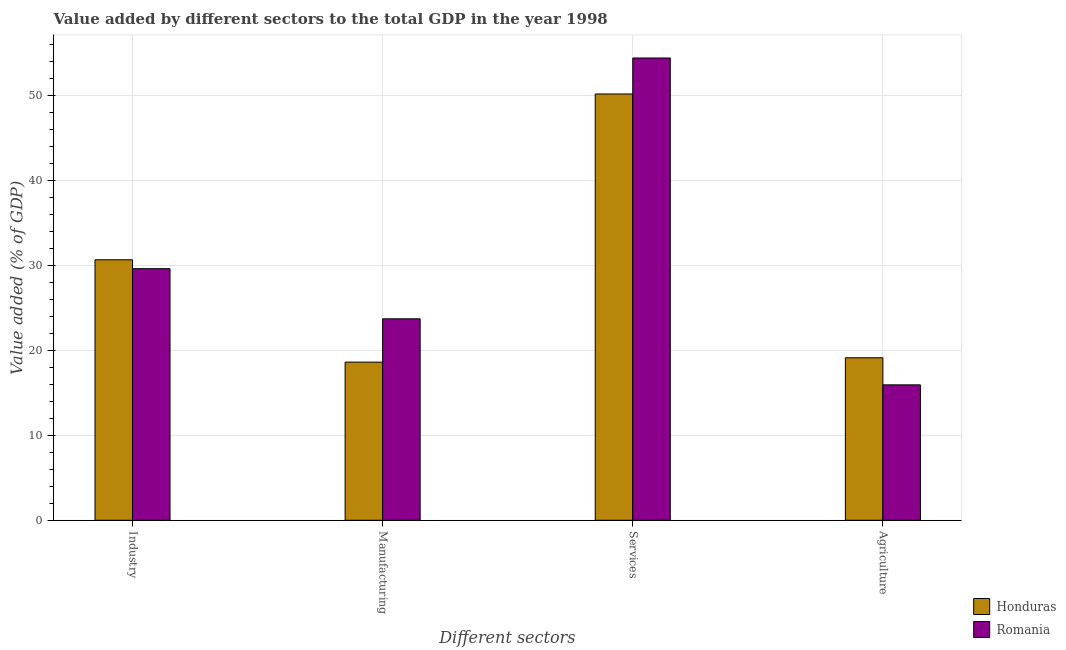How many groups of bars are there?
Keep it short and to the point. 4. Are the number of bars per tick equal to the number of legend labels?
Ensure brevity in your answer.  Yes. Are the number of bars on each tick of the X-axis equal?
Keep it short and to the point. Yes. How many bars are there on the 4th tick from the left?
Give a very brief answer. 2. How many bars are there on the 3rd tick from the right?
Offer a terse response. 2. What is the label of the 4th group of bars from the left?
Keep it short and to the point. Agriculture. What is the value added by industrial sector in Honduras?
Provide a short and direct response. 30.67. Across all countries, what is the maximum value added by industrial sector?
Make the answer very short. 30.67. Across all countries, what is the minimum value added by services sector?
Keep it short and to the point. 50.19. In which country was the value added by agricultural sector maximum?
Ensure brevity in your answer.  Honduras. In which country was the value added by agricultural sector minimum?
Offer a very short reply. Romania. What is the total value added by industrial sector in the graph?
Make the answer very short. 60.3. What is the difference between the value added by agricultural sector in Honduras and that in Romania?
Make the answer very short. 3.19. What is the difference between the value added by industrial sector in Honduras and the value added by agricultural sector in Romania?
Keep it short and to the point. 14.73. What is the average value added by agricultural sector per country?
Offer a very short reply. 17.54. What is the difference between the value added by services sector and value added by industrial sector in Romania?
Keep it short and to the point. 24.81. In how many countries, is the value added by services sector greater than 38 %?
Provide a succinct answer. 2. What is the ratio of the value added by manufacturing sector in Romania to that in Honduras?
Ensure brevity in your answer.  1.27. What is the difference between the highest and the second highest value added by industrial sector?
Your answer should be very brief. 1.05. What is the difference between the highest and the lowest value added by agricultural sector?
Ensure brevity in your answer.  3.19. What does the 2nd bar from the left in Industry represents?
Ensure brevity in your answer.  Romania. What does the 2nd bar from the right in Industry represents?
Your answer should be compact. Honduras. Are all the bars in the graph horizontal?
Your response must be concise. No. What is the difference between two consecutive major ticks on the Y-axis?
Make the answer very short. 10. How many legend labels are there?
Ensure brevity in your answer.  2. What is the title of the graph?
Make the answer very short. Value added by different sectors to the total GDP in the year 1998. Does "Micronesia" appear as one of the legend labels in the graph?
Ensure brevity in your answer.  No. What is the label or title of the X-axis?
Your answer should be very brief. Different sectors. What is the label or title of the Y-axis?
Ensure brevity in your answer.  Value added (% of GDP). What is the Value added (% of GDP) of Honduras in Industry?
Your answer should be compact. 30.67. What is the Value added (% of GDP) in Romania in Industry?
Your answer should be very brief. 29.62. What is the Value added (% of GDP) in Honduras in Manufacturing?
Your answer should be very brief. 18.62. What is the Value added (% of GDP) in Romania in Manufacturing?
Your response must be concise. 23.72. What is the Value added (% of GDP) in Honduras in Services?
Provide a short and direct response. 50.19. What is the Value added (% of GDP) in Romania in Services?
Your response must be concise. 54.43. What is the Value added (% of GDP) of Honduras in Agriculture?
Your answer should be very brief. 19.13. What is the Value added (% of GDP) in Romania in Agriculture?
Give a very brief answer. 15.94. Across all Different sectors, what is the maximum Value added (% of GDP) in Honduras?
Provide a succinct answer. 50.19. Across all Different sectors, what is the maximum Value added (% of GDP) of Romania?
Ensure brevity in your answer.  54.43. Across all Different sectors, what is the minimum Value added (% of GDP) of Honduras?
Keep it short and to the point. 18.62. Across all Different sectors, what is the minimum Value added (% of GDP) of Romania?
Make the answer very short. 15.94. What is the total Value added (% of GDP) in Honduras in the graph?
Offer a terse response. 118.62. What is the total Value added (% of GDP) in Romania in the graph?
Your answer should be very brief. 123.72. What is the difference between the Value added (% of GDP) in Honduras in Industry and that in Manufacturing?
Ensure brevity in your answer.  12.05. What is the difference between the Value added (% of GDP) of Romania in Industry and that in Manufacturing?
Ensure brevity in your answer.  5.9. What is the difference between the Value added (% of GDP) in Honduras in Industry and that in Services?
Provide a succinct answer. -19.52. What is the difference between the Value added (% of GDP) of Romania in Industry and that in Services?
Your answer should be compact. -24.81. What is the difference between the Value added (% of GDP) of Honduras in Industry and that in Agriculture?
Your response must be concise. 11.54. What is the difference between the Value added (% of GDP) of Romania in Industry and that in Agriculture?
Offer a very short reply. 13.68. What is the difference between the Value added (% of GDP) in Honduras in Manufacturing and that in Services?
Offer a very short reply. -31.57. What is the difference between the Value added (% of GDP) of Romania in Manufacturing and that in Services?
Provide a succinct answer. -30.71. What is the difference between the Value added (% of GDP) of Honduras in Manufacturing and that in Agriculture?
Your response must be concise. -0.51. What is the difference between the Value added (% of GDP) in Romania in Manufacturing and that in Agriculture?
Offer a very short reply. 7.78. What is the difference between the Value added (% of GDP) of Honduras in Services and that in Agriculture?
Make the answer very short. 31.06. What is the difference between the Value added (% of GDP) in Romania in Services and that in Agriculture?
Provide a succinct answer. 38.49. What is the difference between the Value added (% of GDP) of Honduras in Industry and the Value added (% of GDP) of Romania in Manufacturing?
Offer a very short reply. 6.95. What is the difference between the Value added (% of GDP) of Honduras in Industry and the Value added (% of GDP) of Romania in Services?
Offer a very short reply. -23.76. What is the difference between the Value added (% of GDP) in Honduras in Industry and the Value added (% of GDP) in Romania in Agriculture?
Offer a very short reply. 14.73. What is the difference between the Value added (% of GDP) of Honduras in Manufacturing and the Value added (% of GDP) of Romania in Services?
Provide a short and direct response. -35.81. What is the difference between the Value added (% of GDP) of Honduras in Manufacturing and the Value added (% of GDP) of Romania in Agriculture?
Give a very brief answer. 2.68. What is the difference between the Value added (% of GDP) of Honduras in Services and the Value added (% of GDP) of Romania in Agriculture?
Offer a very short reply. 34.25. What is the average Value added (% of GDP) of Honduras per Different sectors?
Keep it short and to the point. 29.66. What is the average Value added (% of GDP) of Romania per Different sectors?
Your answer should be very brief. 30.93. What is the difference between the Value added (% of GDP) in Honduras and Value added (% of GDP) in Romania in Industry?
Make the answer very short. 1.05. What is the difference between the Value added (% of GDP) in Honduras and Value added (% of GDP) in Romania in Manufacturing?
Make the answer very short. -5.1. What is the difference between the Value added (% of GDP) in Honduras and Value added (% of GDP) in Romania in Services?
Your answer should be very brief. -4.24. What is the difference between the Value added (% of GDP) of Honduras and Value added (% of GDP) of Romania in Agriculture?
Provide a short and direct response. 3.19. What is the ratio of the Value added (% of GDP) in Honduras in Industry to that in Manufacturing?
Offer a terse response. 1.65. What is the ratio of the Value added (% of GDP) of Romania in Industry to that in Manufacturing?
Your response must be concise. 1.25. What is the ratio of the Value added (% of GDP) of Honduras in Industry to that in Services?
Offer a terse response. 0.61. What is the ratio of the Value added (% of GDP) of Romania in Industry to that in Services?
Keep it short and to the point. 0.54. What is the ratio of the Value added (% of GDP) of Honduras in Industry to that in Agriculture?
Ensure brevity in your answer.  1.6. What is the ratio of the Value added (% of GDP) of Romania in Industry to that in Agriculture?
Offer a very short reply. 1.86. What is the ratio of the Value added (% of GDP) of Honduras in Manufacturing to that in Services?
Your response must be concise. 0.37. What is the ratio of the Value added (% of GDP) of Romania in Manufacturing to that in Services?
Ensure brevity in your answer.  0.44. What is the ratio of the Value added (% of GDP) in Honduras in Manufacturing to that in Agriculture?
Your answer should be very brief. 0.97. What is the ratio of the Value added (% of GDP) in Romania in Manufacturing to that in Agriculture?
Offer a very short reply. 1.49. What is the ratio of the Value added (% of GDP) of Honduras in Services to that in Agriculture?
Keep it short and to the point. 2.62. What is the ratio of the Value added (% of GDP) in Romania in Services to that in Agriculture?
Your answer should be compact. 3.41. What is the difference between the highest and the second highest Value added (% of GDP) of Honduras?
Your answer should be very brief. 19.52. What is the difference between the highest and the second highest Value added (% of GDP) of Romania?
Your answer should be compact. 24.81. What is the difference between the highest and the lowest Value added (% of GDP) in Honduras?
Your answer should be compact. 31.57. What is the difference between the highest and the lowest Value added (% of GDP) of Romania?
Offer a very short reply. 38.49. 